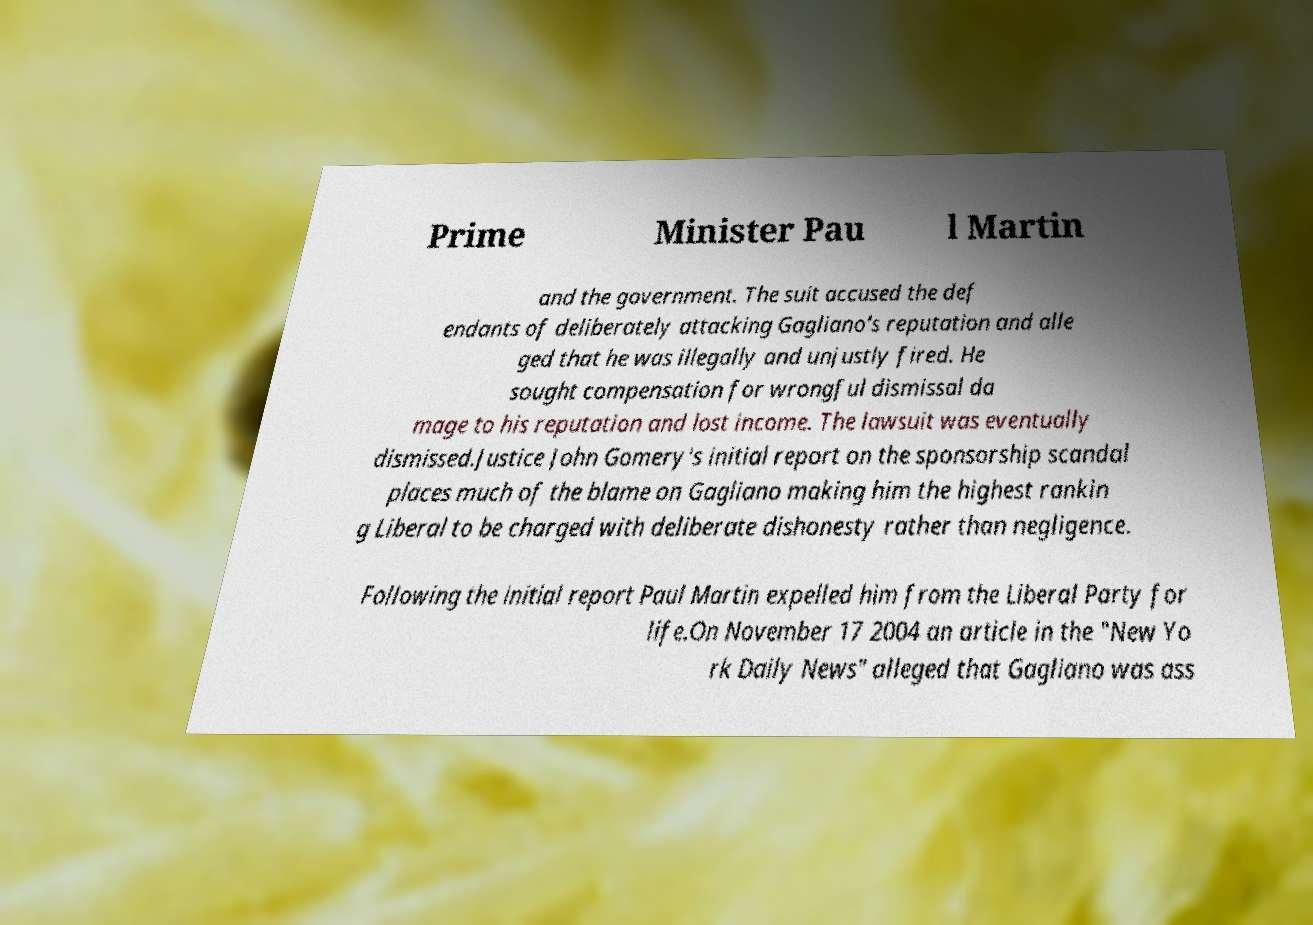I need the written content from this picture converted into text. Can you do that? Prime Minister Pau l Martin and the government. The suit accused the def endants of deliberately attacking Gagliano's reputation and alle ged that he was illegally and unjustly fired. He sought compensation for wrongful dismissal da mage to his reputation and lost income. The lawsuit was eventually dismissed.Justice John Gomery's initial report on the sponsorship scandal places much of the blame on Gagliano making him the highest rankin g Liberal to be charged with deliberate dishonesty rather than negligence. Following the initial report Paul Martin expelled him from the Liberal Party for life.On November 17 2004 an article in the "New Yo rk Daily News" alleged that Gagliano was ass 